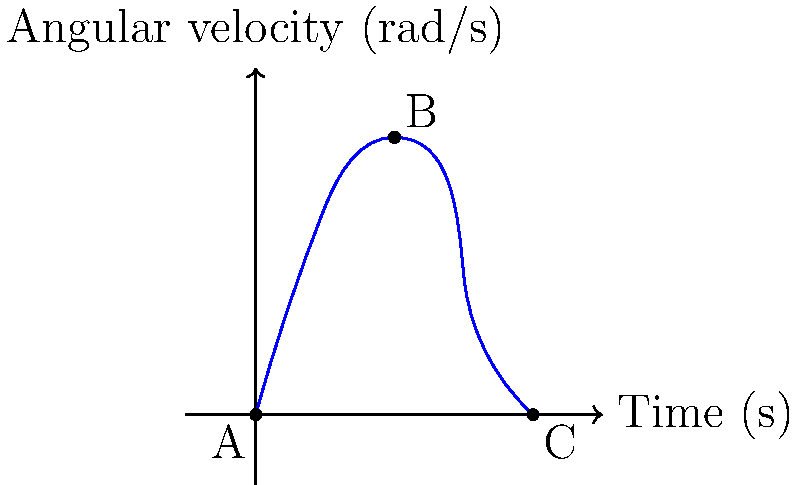A gymnast performs a backflip, and their angular velocity is recorded over time as shown in the graph above. If the gymnast's moment of inertia about their rotation axis is $2.5 \text{ kg}\cdot\text{m}^2$, what is the total work done by the gymnast during the backflip (from point A to point C)? To solve this problem, we need to follow these steps:

1) The work done is equal to the change in rotational kinetic energy:
   $$W = \Delta KE = KE_f - KE_i$$

2) Rotational kinetic energy is given by:
   $$KE = \frac{1}{2}I\omega^2$$
   where $I$ is the moment of inertia and $\omega$ is the angular velocity.

3) We're given that $I = 2.5 \text{ kg}\cdot\text{m}^2$.

4) From the graph:
   - Initial angular velocity (at A): $\omega_i = 0 \text{ rad/s}$
   - Final angular velocity (at C): $\omega_f = 0 \text{ rad/s}$

5) Calculate initial and final kinetic energies:
   $$KE_i = \frac{1}{2}(2.5)(0^2) = 0 \text{ J}$$
   $$KE_f = \frac{1}{2}(2.5)(0^2) = 0 \text{ J}$$

6) Calculate the work done:
   $$W = KE_f - KE_i = 0 - 0 = 0 \text{ J}$$

Therefore, the total work done by the gymnast during the backflip is 0 J.

Note: This result might seem counterintuitive, but it's correct because we're considering the entire motion from start to finish. The gymnast does positive work to initiate the rotation and negative work to stop it, which cancel out over the complete motion.
Answer: 0 J 